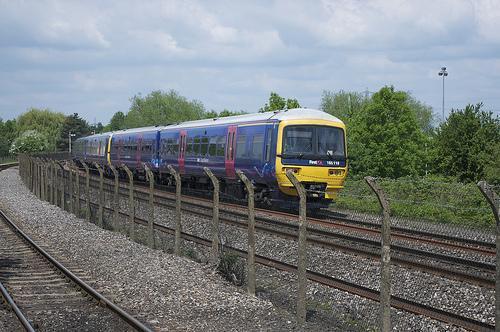How many trains are there in this photo?
Give a very brief answer. 1. 